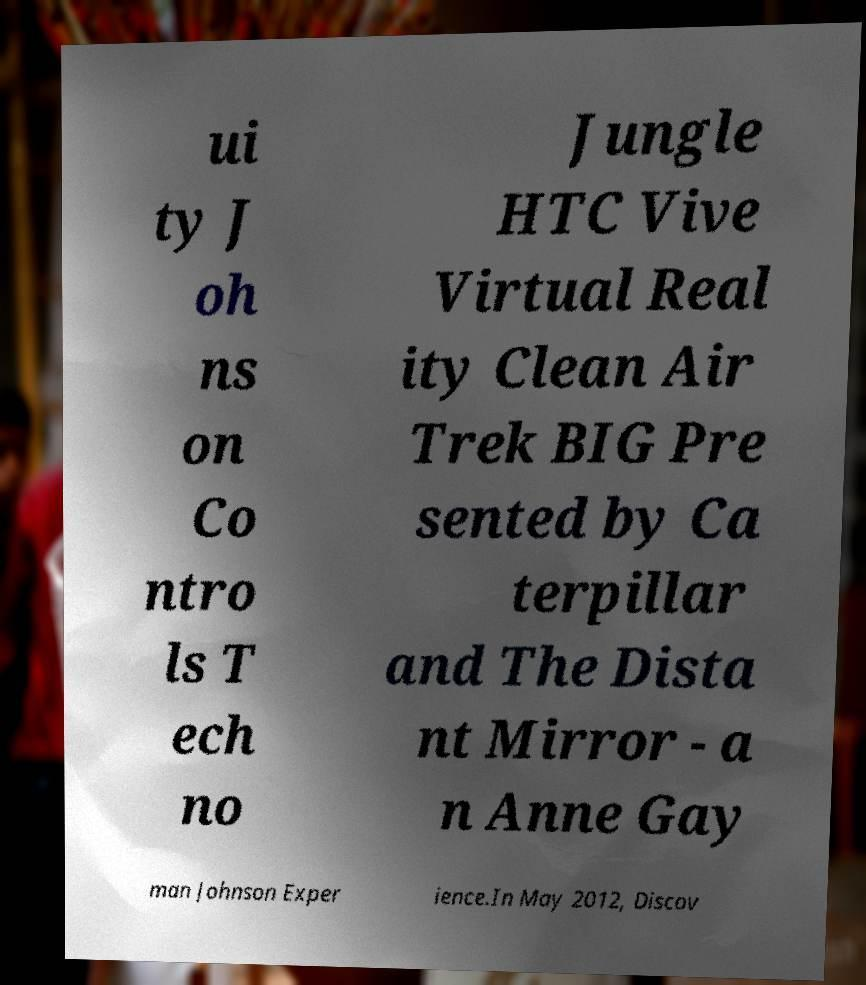Can you accurately transcribe the text from the provided image for me? ui ty J oh ns on Co ntro ls T ech no Jungle HTC Vive Virtual Real ity Clean Air Trek BIG Pre sented by Ca terpillar and The Dista nt Mirror - a n Anne Gay man Johnson Exper ience.In May 2012, Discov 